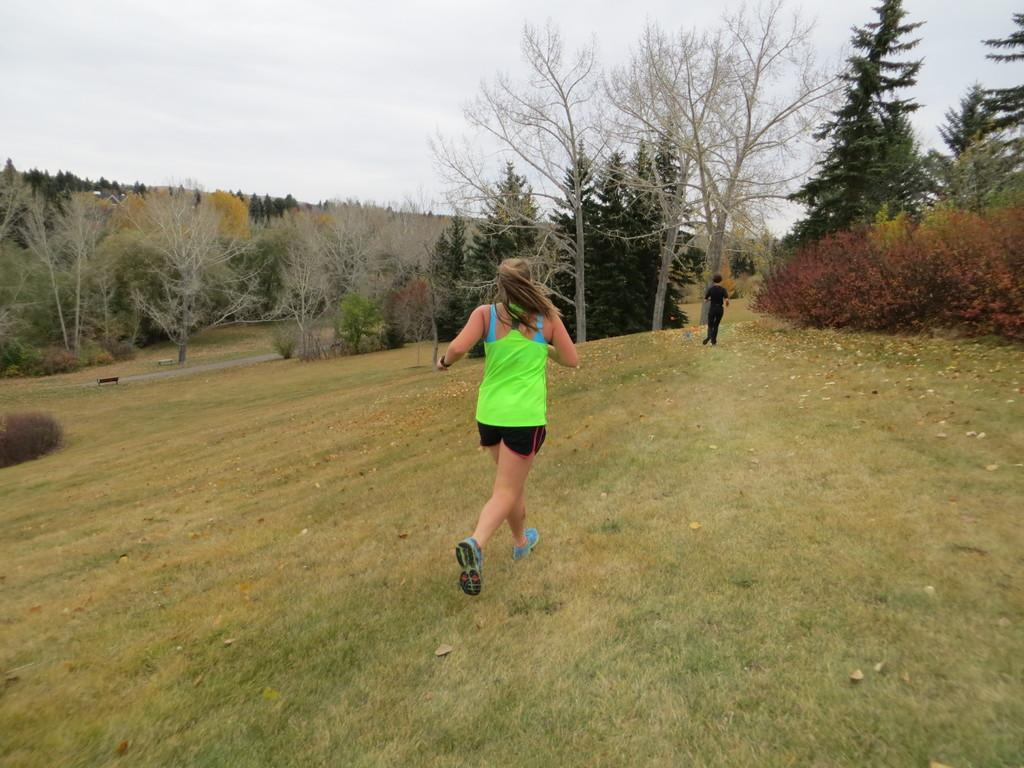In one or two sentences, can you explain what this image depicts? There is one woman running on a grassy land as we can see at the bottom of this image. We can see trees in the middle of this image. It seems like a person standing on the right side of this image and the sky is in the background. 